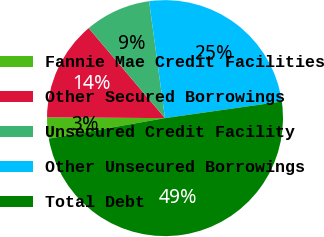Convert chart. <chart><loc_0><loc_0><loc_500><loc_500><pie_chart><fcel>Fannie Mae Credit Facilities<fcel>Other Secured Borrowings<fcel>Unsecured Credit Facility<fcel>Other Unsecured Borrowings<fcel>Total Debt<nl><fcel>2.89%<fcel>13.7%<fcel>9.04%<fcel>24.91%<fcel>49.46%<nl></chart> 